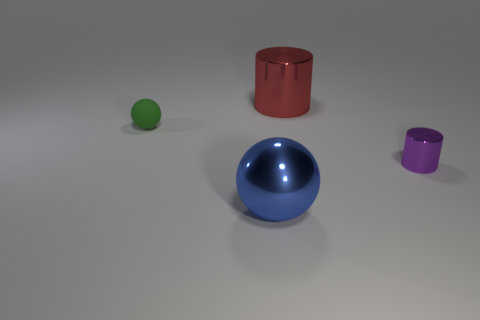Subtract all purple cylinders. Subtract all yellow blocks. How many cylinders are left? 1 Add 3 small matte things. How many objects exist? 7 Subtract all green things. Subtract all tiny blue matte spheres. How many objects are left? 3 Add 1 red metallic things. How many red metallic things are left? 2 Add 1 tiny objects. How many tiny objects exist? 3 Subtract 0 gray blocks. How many objects are left? 4 